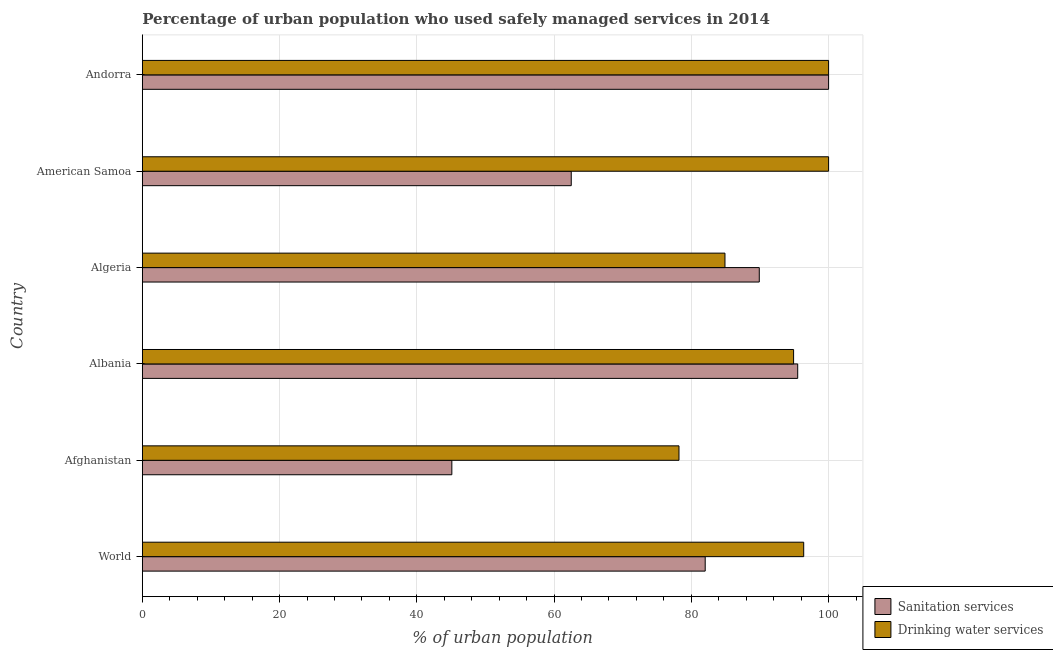How many groups of bars are there?
Your answer should be very brief. 6. How many bars are there on the 4th tick from the bottom?
Offer a terse response. 2. What is the label of the 1st group of bars from the top?
Ensure brevity in your answer.  Andorra. In how many cases, is the number of bars for a given country not equal to the number of legend labels?
Make the answer very short. 0. Across all countries, what is the maximum percentage of urban population who used drinking water services?
Provide a succinct answer. 100. Across all countries, what is the minimum percentage of urban population who used sanitation services?
Offer a terse response. 45.1. In which country was the percentage of urban population who used sanitation services maximum?
Provide a succinct answer. Andorra. In which country was the percentage of urban population who used drinking water services minimum?
Offer a very short reply. Afghanistan. What is the total percentage of urban population who used drinking water services in the graph?
Give a very brief answer. 554.38. What is the difference between the percentage of urban population who used sanitation services in Afghanistan and that in Albania?
Provide a short and direct response. -50.4. What is the difference between the percentage of urban population who used drinking water services in Andorra and the percentage of urban population who used sanitation services in Afghanistan?
Ensure brevity in your answer.  54.9. What is the average percentage of urban population who used sanitation services per country?
Offer a terse response. 79.17. What is the difference between the percentage of urban population who used drinking water services and percentage of urban population who used sanitation services in Afghanistan?
Give a very brief answer. 33.1. In how many countries, is the percentage of urban population who used drinking water services greater than 12 %?
Ensure brevity in your answer.  6. What is the ratio of the percentage of urban population who used sanitation services in Algeria to that in American Samoa?
Make the answer very short. 1.44. Is the percentage of urban population who used drinking water services in Albania less than that in World?
Provide a short and direct response. Yes. Is the difference between the percentage of urban population who used sanitation services in Albania and World greater than the difference between the percentage of urban population who used drinking water services in Albania and World?
Provide a succinct answer. Yes. What is the difference between the highest and the second highest percentage of urban population who used sanitation services?
Your answer should be very brief. 4.5. What is the difference between the highest and the lowest percentage of urban population who used sanitation services?
Ensure brevity in your answer.  54.9. In how many countries, is the percentage of urban population who used drinking water services greater than the average percentage of urban population who used drinking water services taken over all countries?
Your response must be concise. 4. Is the sum of the percentage of urban population who used drinking water services in Afghanistan and American Samoa greater than the maximum percentage of urban population who used sanitation services across all countries?
Keep it short and to the point. Yes. What does the 1st bar from the top in Andorra represents?
Keep it short and to the point. Drinking water services. What does the 1st bar from the bottom in Albania represents?
Offer a very short reply. Sanitation services. How many bars are there?
Keep it short and to the point. 12. Are the values on the major ticks of X-axis written in scientific E-notation?
Keep it short and to the point. No. Does the graph contain grids?
Your answer should be compact. Yes. Where does the legend appear in the graph?
Your answer should be very brief. Bottom right. How many legend labels are there?
Provide a succinct answer. 2. What is the title of the graph?
Make the answer very short. Percentage of urban population who used safely managed services in 2014. What is the label or title of the X-axis?
Keep it short and to the point. % of urban population. What is the label or title of the Y-axis?
Give a very brief answer. Country. What is the % of urban population of Sanitation services in World?
Offer a very short reply. 82.02. What is the % of urban population in Drinking water services in World?
Provide a succinct answer. 96.38. What is the % of urban population of Sanitation services in Afghanistan?
Make the answer very short. 45.1. What is the % of urban population of Drinking water services in Afghanistan?
Offer a terse response. 78.2. What is the % of urban population of Sanitation services in Albania?
Ensure brevity in your answer.  95.5. What is the % of urban population in Drinking water services in Albania?
Keep it short and to the point. 94.9. What is the % of urban population of Sanitation services in Algeria?
Your answer should be compact. 89.9. What is the % of urban population of Drinking water services in Algeria?
Give a very brief answer. 84.9. What is the % of urban population of Sanitation services in American Samoa?
Ensure brevity in your answer.  62.5. What is the % of urban population in Sanitation services in Andorra?
Ensure brevity in your answer.  100. Across all countries, what is the maximum % of urban population of Sanitation services?
Offer a very short reply. 100. Across all countries, what is the maximum % of urban population in Drinking water services?
Make the answer very short. 100. Across all countries, what is the minimum % of urban population in Sanitation services?
Keep it short and to the point. 45.1. Across all countries, what is the minimum % of urban population of Drinking water services?
Offer a very short reply. 78.2. What is the total % of urban population in Sanitation services in the graph?
Provide a short and direct response. 475.02. What is the total % of urban population in Drinking water services in the graph?
Offer a very short reply. 554.38. What is the difference between the % of urban population of Sanitation services in World and that in Afghanistan?
Offer a terse response. 36.92. What is the difference between the % of urban population in Drinking water services in World and that in Afghanistan?
Offer a terse response. 18.18. What is the difference between the % of urban population in Sanitation services in World and that in Albania?
Provide a succinct answer. -13.48. What is the difference between the % of urban population in Drinking water services in World and that in Albania?
Provide a succinct answer. 1.48. What is the difference between the % of urban population of Sanitation services in World and that in Algeria?
Your answer should be very brief. -7.88. What is the difference between the % of urban population in Drinking water services in World and that in Algeria?
Make the answer very short. 11.47. What is the difference between the % of urban population in Sanitation services in World and that in American Samoa?
Ensure brevity in your answer.  19.52. What is the difference between the % of urban population in Drinking water services in World and that in American Samoa?
Your answer should be compact. -3.62. What is the difference between the % of urban population of Sanitation services in World and that in Andorra?
Make the answer very short. -17.98. What is the difference between the % of urban population in Drinking water services in World and that in Andorra?
Keep it short and to the point. -3.62. What is the difference between the % of urban population in Sanitation services in Afghanistan and that in Albania?
Provide a short and direct response. -50.4. What is the difference between the % of urban population in Drinking water services in Afghanistan and that in Albania?
Keep it short and to the point. -16.7. What is the difference between the % of urban population of Sanitation services in Afghanistan and that in Algeria?
Your answer should be compact. -44.8. What is the difference between the % of urban population of Drinking water services in Afghanistan and that in Algeria?
Offer a terse response. -6.7. What is the difference between the % of urban population in Sanitation services in Afghanistan and that in American Samoa?
Your response must be concise. -17.4. What is the difference between the % of urban population of Drinking water services in Afghanistan and that in American Samoa?
Make the answer very short. -21.8. What is the difference between the % of urban population in Sanitation services in Afghanistan and that in Andorra?
Keep it short and to the point. -54.9. What is the difference between the % of urban population in Drinking water services in Afghanistan and that in Andorra?
Give a very brief answer. -21.8. What is the difference between the % of urban population in Sanitation services in Albania and that in American Samoa?
Your answer should be very brief. 33. What is the difference between the % of urban population of Sanitation services in Albania and that in Andorra?
Keep it short and to the point. -4.5. What is the difference between the % of urban population of Sanitation services in Algeria and that in American Samoa?
Offer a very short reply. 27.4. What is the difference between the % of urban population in Drinking water services in Algeria and that in American Samoa?
Give a very brief answer. -15.1. What is the difference between the % of urban population of Sanitation services in Algeria and that in Andorra?
Make the answer very short. -10.1. What is the difference between the % of urban population in Drinking water services in Algeria and that in Andorra?
Offer a terse response. -15.1. What is the difference between the % of urban population in Sanitation services in American Samoa and that in Andorra?
Your answer should be very brief. -37.5. What is the difference between the % of urban population in Sanitation services in World and the % of urban population in Drinking water services in Afghanistan?
Provide a short and direct response. 3.82. What is the difference between the % of urban population of Sanitation services in World and the % of urban population of Drinking water services in Albania?
Your response must be concise. -12.88. What is the difference between the % of urban population in Sanitation services in World and the % of urban population in Drinking water services in Algeria?
Your answer should be very brief. -2.88. What is the difference between the % of urban population of Sanitation services in World and the % of urban population of Drinking water services in American Samoa?
Give a very brief answer. -17.98. What is the difference between the % of urban population of Sanitation services in World and the % of urban population of Drinking water services in Andorra?
Make the answer very short. -17.98. What is the difference between the % of urban population of Sanitation services in Afghanistan and the % of urban population of Drinking water services in Albania?
Provide a succinct answer. -49.8. What is the difference between the % of urban population of Sanitation services in Afghanistan and the % of urban population of Drinking water services in Algeria?
Your answer should be very brief. -39.8. What is the difference between the % of urban population of Sanitation services in Afghanistan and the % of urban population of Drinking water services in American Samoa?
Offer a terse response. -54.9. What is the difference between the % of urban population in Sanitation services in Afghanistan and the % of urban population in Drinking water services in Andorra?
Your answer should be very brief. -54.9. What is the difference between the % of urban population of Sanitation services in Albania and the % of urban population of Drinking water services in American Samoa?
Provide a short and direct response. -4.5. What is the difference between the % of urban population in Sanitation services in Algeria and the % of urban population in Drinking water services in Andorra?
Give a very brief answer. -10.1. What is the difference between the % of urban population of Sanitation services in American Samoa and the % of urban population of Drinking water services in Andorra?
Your answer should be very brief. -37.5. What is the average % of urban population in Sanitation services per country?
Your answer should be compact. 79.17. What is the average % of urban population of Drinking water services per country?
Make the answer very short. 92.4. What is the difference between the % of urban population of Sanitation services and % of urban population of Drinking water services in World?
Your answer should be compact. -14.35. What is the difference between the % of urban population in Sanitation services and % of urban population in Drinking water services in Afghanistan?
Give a very brief answer. -33.1. What is the difference between the % of urban population in Sanitation services and % of urban population in Drinking water services in American Samoa?
Offer a terse response. -37.5. What is the difference between the % of urban population in Sanitation services and % of urban population in Drinking water services in Andorra?
Your answer should be very brief. 0. What is the ratio of the % of urban population in Sanitation services in World to that in Afghanistan?
Provide a short and direct response. 1.82. What is the ratio of the % of urban population in Drinking water services in World to that in Afghanistan?
Make the answer very short. 1.23. What is the ratio of the % of urban population of Sanitation services in World to that in Albania?
Ensure brevity in your answer.  0.86. What is the ratio of the % of urban population of Drinking water services in World to that in Albania?
Keep it short and to the point. 1.02. What is the ratio of the % of urban population of Sanitation services in World to that in Algeria?
Make the answer very short. 0.91. What is the ratio of the % of urban population in Drinking water services in World to that in Algeria?
Provide a short and direct response. 1.14. What is the ratio of the % of urban population in Sanitation services in World to that in American Samoa?
Offer a very short reply. 1.31. What is the ratio of the % of urban population of Drinking water services in World to that in American Samoa?
Keep it short and to the point. 0.96. What is the ratio of the % of urban population in Sanitation services in World to that in Andorra?
Offer a very short reply. 0.82. What is the ratio of the % of urban population in Drinking water services in World to that in Andorra?
Your answer should be very brief. 0.96. What is the ratio of the % of urban population of Sanitation services in Afghanistan to that in Albania?
Keep it short and to the point. 0.47. What is the ratio of the % of urban population in Drinking water services in Afghanistan to that in Albania?
Offer a very short reply. 0.82. What is the ratio of the % of urban population in Sanitation services in Afghanistan to that in Algeria?
Give a very brief answer. 0.5. What is the ratio of the % of urban population in Drinking water services in Afghanistan to that in Algeria?
Keep it short and to the point. 0.92. What is the ratio of the % of urban population of Sanitation services in Afghanistan to that in American Samoa?
Your answer should be very brief. 0.72. What is the ratio of the % of urban population of Drinking water services in Afghanistan to that in American Samoa?
Your answer should be compact. 0.78. What is the ratio of the % of urban population of Sanitation services in Afghanistan to that in Andorra?
Provide a succinct answer. 0.45. What is the ratio of the % of urban population of Drinking water services in Afghanistan to that in Andorra?
Offer a terse response. 0.78. What is the ratio of the % of urban population in Sanitation services in Albania to that in Algeria?
Your response must be concise. 1.06. What is the ratio of the % of urban population of Drinking water services in Albania to that in Algeria?
Your answer should be very brief. 1.12. What is the ratio of the % of urban population of Sanitation services in Albania to that in American Samoa?
Provide a succinct answer. 1.53. What is the ratio of the % of urban population of Drinking water services in Albania to that in American Samoa?
Provide a short and direct response. 0.95. What is the ratio of the % of urban population of Sanitation services in Albania to that in Andorra?
Your answer should be compact. 0.95. What is the ratio of the % of urban population of Drinking water services in Albania to that in Andorra?
Provide a succinct answer. 0.95. What is the ratio of the % of urban population in Sanitation services in Algeria to that in American Samoa?
Keep it short and to the point. 1.44. What is the ratio of the % of urban population in Drinking water services in Algeria to that in American Samoa?
Offer a terse response. 0.85. What is the ratio of the % of urban population in Sanitation services in Algeria to that in Andorra?
Provide a succinct answer. 0.9. What is the ratio of the % of urban population of Drinking water services in Algeria to that in Andorra?
Your response must be concise. 0.85. What is the ratio of the % of urban population of Drinking water services in American Samoa to that in Andorra?
Your response must be concise. 1. What is the difference between the highest and the second highest % of urban population of Drinking water services?
Offer a very short reply. 0. What is the difference between the highest and the lowest % of urban population in Sanitation services?
Offer a very short reply. 54.9. What is the difference between the highest and the lowest % of urban population in Drinking water services?
Your answer should be very brief. 21.8. 